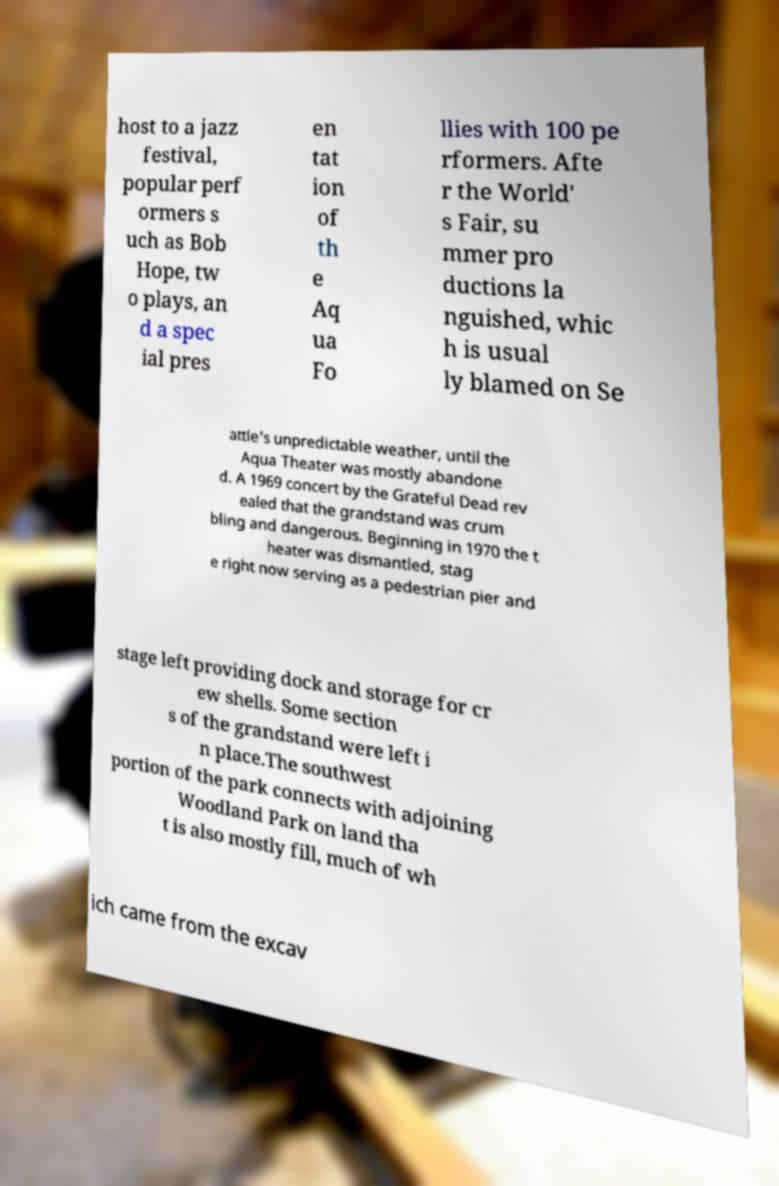Can you accurately transcribe the text from the provided image for me? host to a jazz festival, popular perf ormers s uch as Bob Hope, tw o plays, an d a spec ial pres en tat ion of th e Aq ua Fo llies with 100 pe rformers. Afte r the World' s Fair, su mmer pro ductions la nguished, whic h is usual ly blamed on Se attle's unpredictable weather, until the Aqua Theater was mostly abandone d. A 1969 concert by the Grateful Dead rev ealed that the grandstand was crum bling and dangerous. Beginning in 1970 the t heater was dismantled, stag e right now serving as a pedestrian pier and stage left providing dock and storage for cr ew shells. Some section s of the grandstand were left i n place.The southwest portion of the park connects with adjoining Woodland Park on land tha t is also mostly fill, much of wh ich came from the excav 